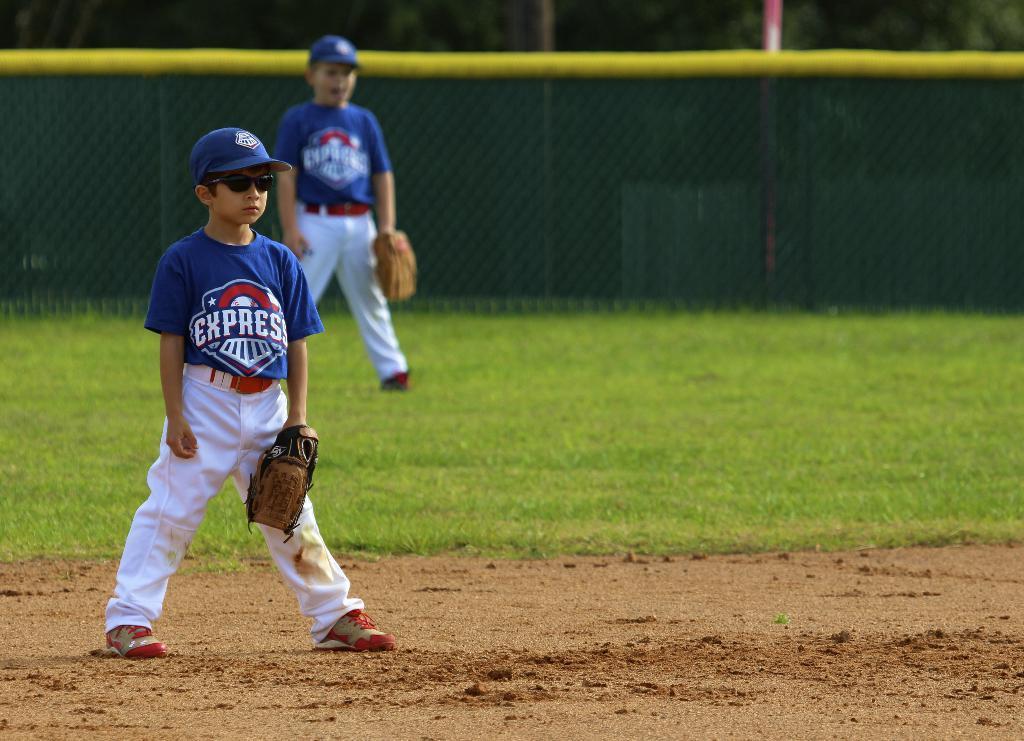Please provide a concise description of this image. In this picture I can see two kids are standing. These kids are wearing blue color t-shirt, cap, white color pant and some other objects. In the background I can see a net, grass and poles. 